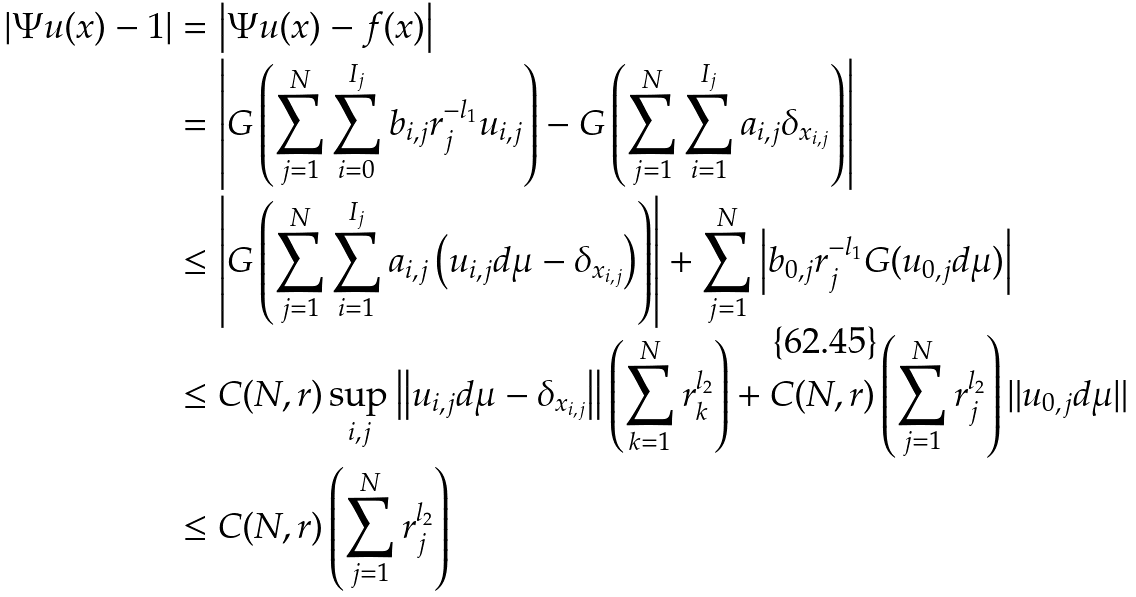<formula> <loc_0><loc_0><loc_500><loc_500>\left | \Psi u ( x ) - 1 \right | & = \left | \Psi u ( x ) - f ( x ) \right | \\ & = \left | G \left ( \sum _ { j = 1 } ^ { N } \sum _ { i = 0 } ^ { I _ { j } } b _ { i , j } r _ { j } ^ { - l _ { 1 } } u _ { i , j } \right ) - G \left ( \sum _ { j = 1 } ^ { N } \sum _ { i = 1 } ^ { I _ { j } } a _ { i , j } \delta _ { x _ { i , j } } \right ) \right | \\ & \leq \left | G \left ( \sum _ { j = 1 } ^ { N } \sum _ { i = 1 } ^ { I _ { j } } a _ { i , j } \left ( u _ { i , j } d \mu - \delta _ { x _ { i , j } } \right ) \right ) \right | + \sum _ { j = 1 } ^ { N } \left | b _ { 0 , j } r _ { j } ^ { - l _ { 1 } } G ( u _ { 0 , j } d \mu ) \right | \\ & \leq C ( N , r ) \sup _ { i , j } \left \| u _ { i , j } d \mu - \delta _ { x _ { i , j } } \right \| \left ( \sum _ { k = 1 } ^ { N } r _ { k } ^ { l _ { 2 } } \right ) + C ( N , r ) \left ( \sum _ { j = 1 } ^ { N } r _ { j } ^ { l _ { 2 } } \right ) \| u _ { 0 , j } d \mu \| \\ & \leq C ( N , r ) \left ( \sum _ { j = 1 } ^ { N } r _ { j } ^ { l _ { 2 } } \right )</formula> 